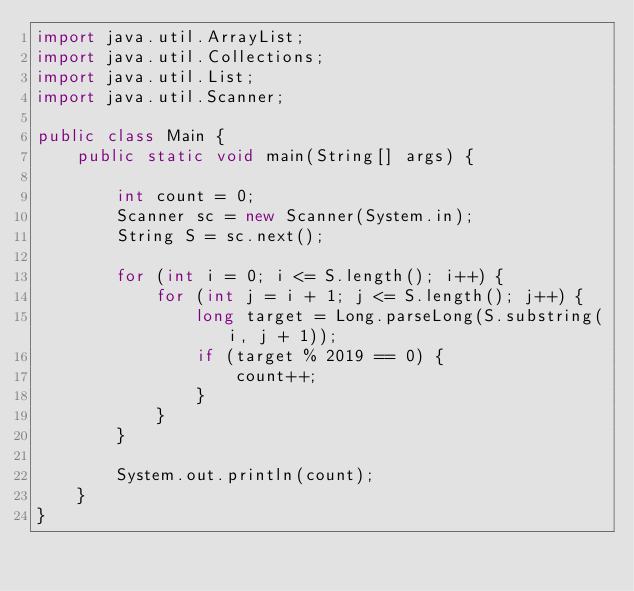<code> <loc_0><loc_0><loc_500><loc_500><_Java_>import java.util.ArrayList;
import java.util.Collections;
import java.util.List;
import java.util.Scanner;

public class Main {
    public static void main(String[] args) {

        int count = 0;
        Scanner sc = new Scanner(System.in);
        String S = sc.next();

        for (int i = 0; i <= S.length(); i++) {
            for (int j = i + 1; j <= S.length(); j++) {
                long target = Long.parseLong(S.substring(i, j + 1));
                if (target % 2019 == 0) {
                    count++;
                }
            }
        }

        System.out.println(count);
    }
}</code> 